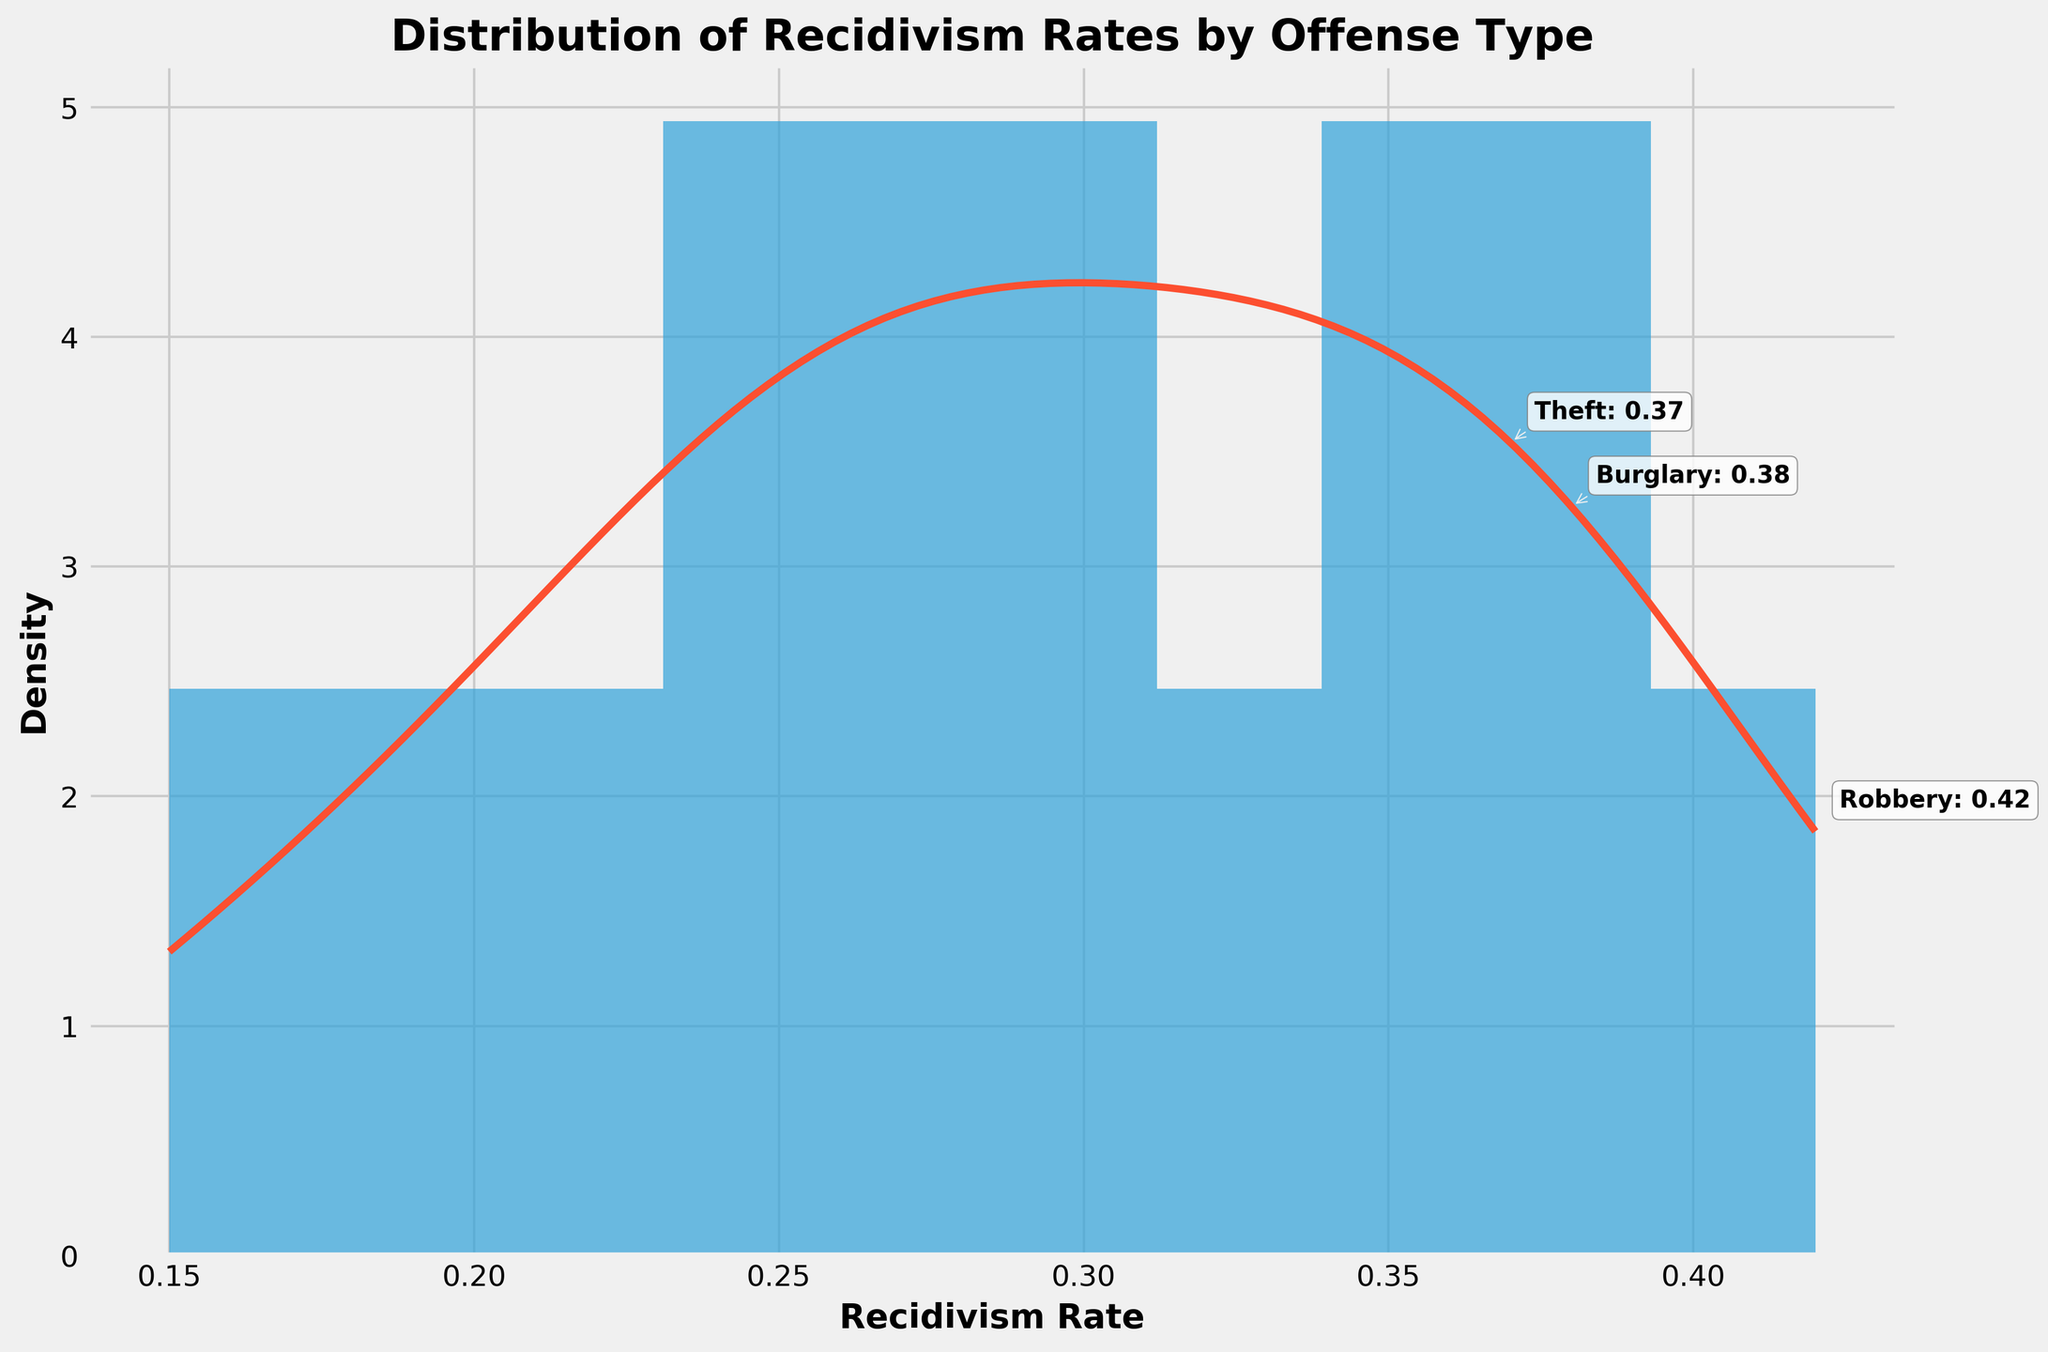What is the title of the figure? The title is displayed at the top of the figure above the plot itself. It often provides a brief description of what the figure represents.
Answer: Distribution of Recidivism Rates by Offense Type What is the maximum value of the recidivism rate on the x-axis? The x-axis of the histogram ranges from the minimum to the maximum recidivism rate values observed in the dataset. The maximum value can be seen as the furthest right tick on the x-axis.
Answer: 0.42 How many offense types have recidivism rates higher than 0.35? Look at the data points above 0.35 on the x-axis and count the corresponding bars. These represent the number of offense types with recidivism rates higher than 0.35.
Answer: 4 Which offense type has the highest recidivism rate, and what is its value? The offense type with the highest recidivism rate is indicated by the text annotations on the plot, and its exact value is provided next to it.
Answer: Robbery, 0.42 What is the range of recidivism rates covered by the KDE curve? The KDE curve spans from the minimum to the maximum recidivism rate values and provides a smoothed estimate of the distribution. Check the starting and ending points of the KDE curve on the x-axis.
Answer: 0.15 to 0.42 Which offense types are annotated on the plot? Annotations on the plot highlight specific offense types, usually the ones with the highest recidivism rates. These are visibly marked with text and arrows.
Answer: Robbery, Burglary, Assault Between which recidivism rates does the histogram have the highest density of observations? Observe the tallest bar in the histogram and note the range of recidivism rates it covers. This indicates where the highest density of observations is located.
Answer: 0.25 to 0.30 How would you describe the overall shape of the KDE curve? Look at the KDE curve's shape as it smooths over the histogram bars. Describe if it is skewed, has peaks, or is relatively flat.
Answer: Slightly positively skewed with a peak around 0.28 to 0.32 What is the approximate density at the recidivism rate of 0.25 according to the KDE curve? On the KDE curve, find the density value at the recidivism rate of 0.25 by following upward from the x-axis to the curve and noting the y-axis value.
Answer: Approximately 6 Which offense type has a lower recidivism rate: Burglary or Theft? Compare the annotated recidivism rates of Burglary and Theft, as shown in the histogram. Look at the x-axis positions for both.
Answer: Theft 